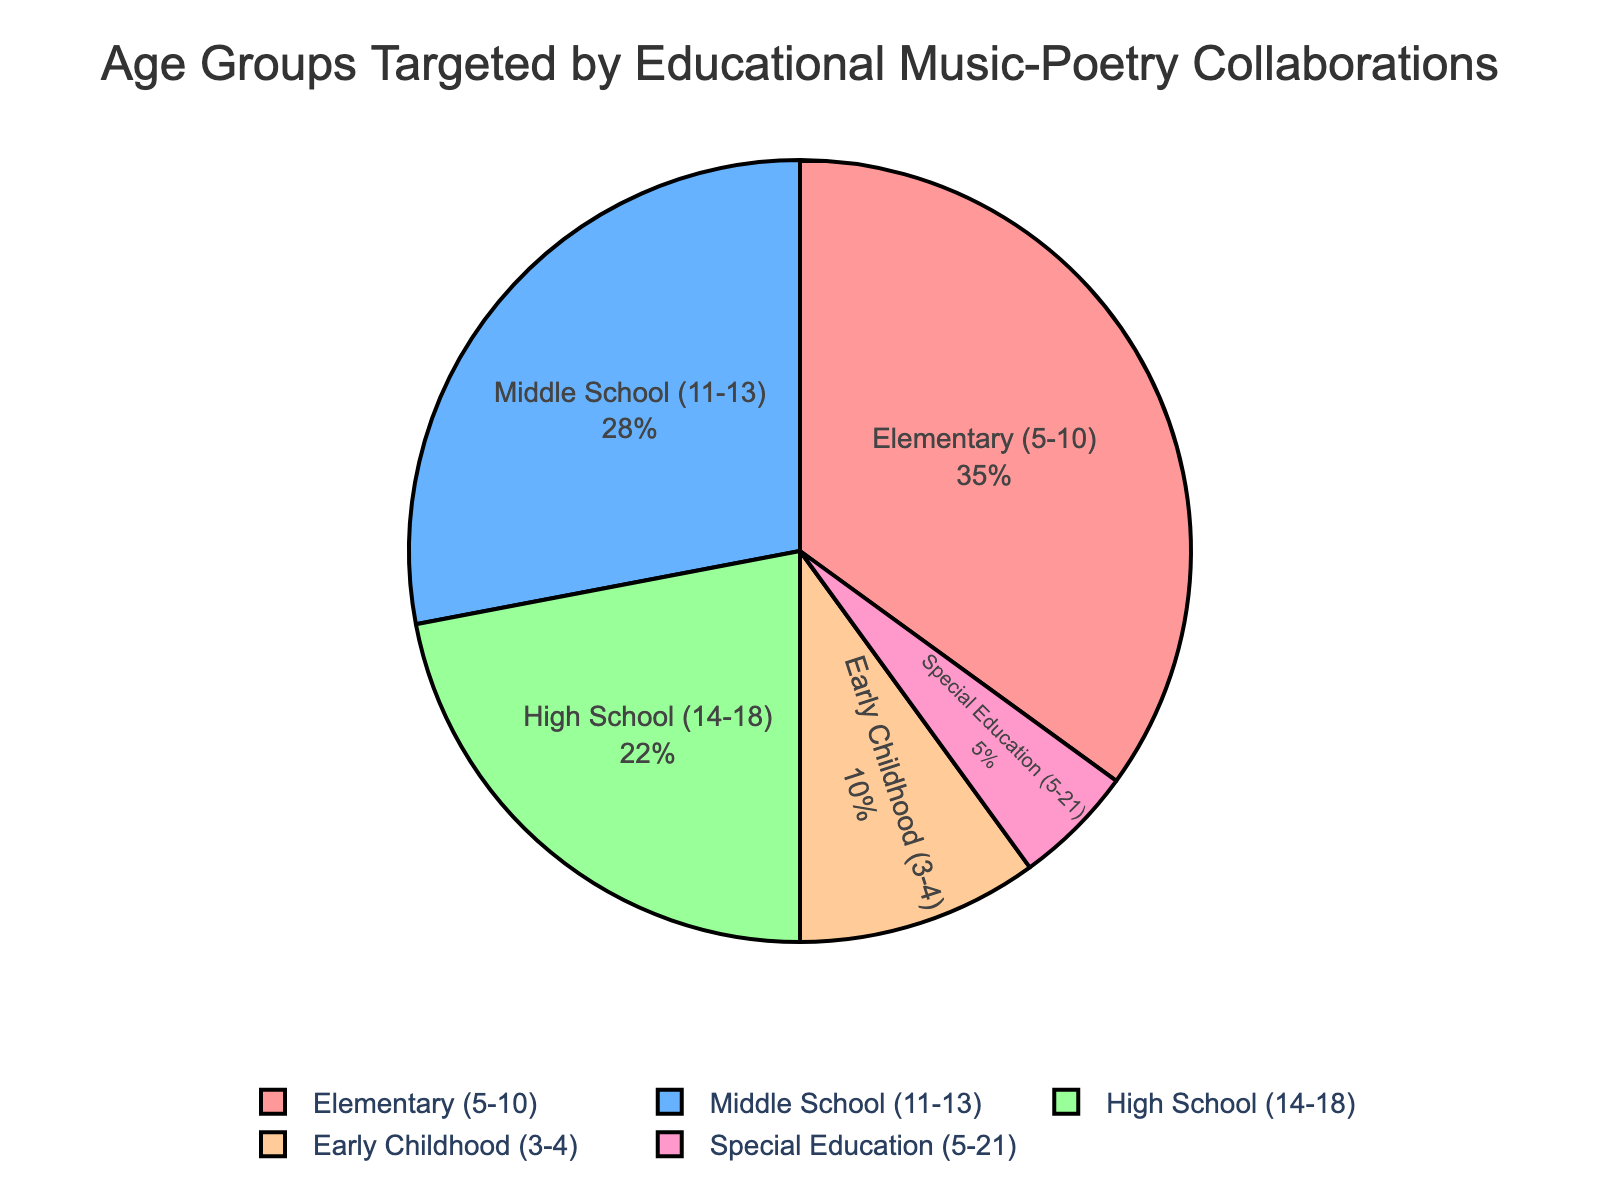which age group has the highest percentage? The largest slice of the pie chart represents the age group with the highest percentage. This can be identified visually or by reading the values. For this chart, the slice for Elementary (5-10) is the largest.
Answer: Elementary (5-10) what is the total percentage of students in Early Childhood and Special Education? Add the percentages of the Early Childhood (3-4) and Special Education (5-21) age groups: 10% and 5% respectively. 10 + 5 = 15
Answer: 15% which age group has a slightly smaller percentage than Middle School (11-13)? By comparing the values, the age group with the slightly smaller percentage than Middle School (11-13) (28%) is High School (14-18) with 22%.
Answer: High School (14-18) what is the percentage difference between the largest and smallest age groups? The largest age group is Elementary (5-10) with 35% and the smallest is Special Education (5-21) with 5%. Subtract the smallest from the largest: 35 - 5 = 30
Answer: 30% what percentage of students are targeted by programs aimed at school-aged children (i.e., excluding Early Childhood)? Sum the percentages for Elementary (35%), Middle School (28%), High School (22%), and Special Education (5%): 35 + 28 + 22 + 5 = 90%
Answer: 90% how much more percentage do Middle School students account for compared to High School students? Subtract the percentage of High School (22%) from Middle School (28%): 28 - 22 = 6%
Answer: 6% what is the combined percentage of Elementary and High School students? Add the percentages of Elementary (35%) and High School (22%) age groups: 35 + 22 = 57%
Answer: 57% how does the total percentage of students in Elementary and Early Childhood compare to Middle School students? Multiply and compare the total percentages of Elementary and Early Childhood with Middle School. Elementary (35%) + Early Childhood (10%) = 45%, which is more than the Middle School percentage (28%).
Answer: More which two age groups combined have the same percentage as Elementary students? Sum the percentages of Middle School (28%) and Special Education (5%) which equals 28 + 5 = 33%, which is close but not equal to 35%. Instead, sum Middle School (28%) and Early Childhood (10%), 28 + 10 = 38%, a slightly higher percentage. Therefore, a more precise combination might be Middle School and a slight portion of Early Childhood.
Answer: No precise equal what is the percentage difference between High School students and Early Childhood students? Subtract the Early Childhood (10%) percentage from High School (22%) percentage: 22 - 10 = 12%
Answer: 12% 